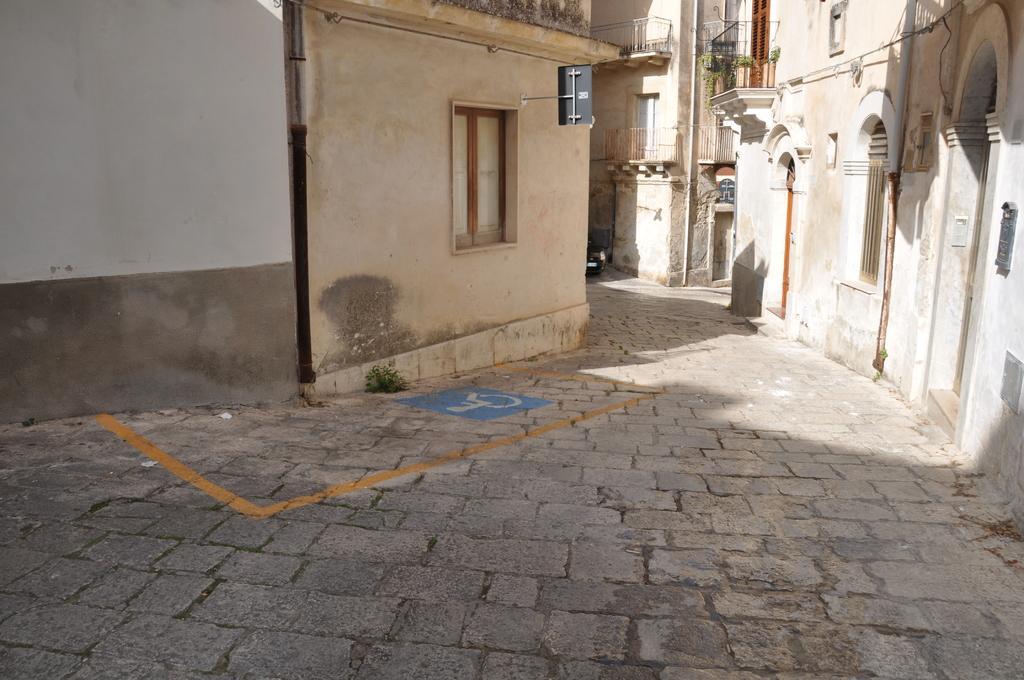In one or two sentences, can you explain what this image depicts? This picture is clicked outside. On the left we can see the building and the window of the building. On the right we can see the plants, arch on the building, deck rails, doors and windows of the buildings. In the center we can see the pavement. In the background there is a black color vehicle. 